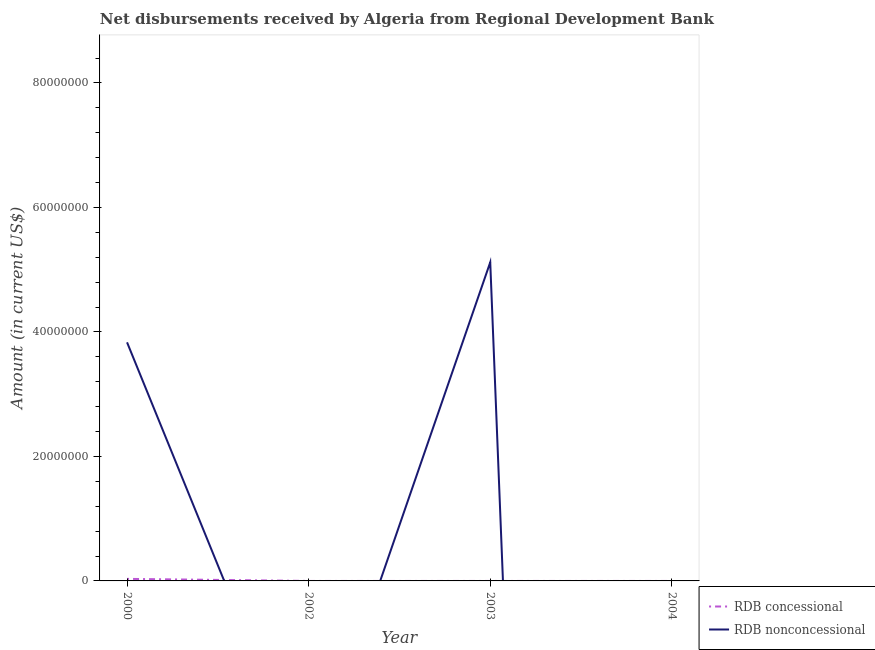Across all years, what is the maximum net non concessional disbursements from rdb?
Ensure brevity in your answer.  5.12e+07. Across all years, what is the minimum net non concessional disbursements from rdb?
Offer a very short reply. 0. What is the total net non concessional disbursements from rdb in the graph?
Offer a very short reply. 8.95e+07. What is the average net concessional disbursements from rdb per year?
Your response must be concise. 8.25e+04. In the year 2000, what is the difference between the net concessional disbursements from rdb and net non concessional disbursements from rdb?
Offer a very short reply. -3.80e+07. What is the difference between the highest and the lowest net non concessional disbursements from rdb?
Provide a succinct answer. 5.12e+07. Is the sum of the net non concessional disbursements from rdb in 2000 and 2003 greater than the maximum net concessional disbursements from rdb across all years?
Make the answer very short. Yes. Is the net non concessional disbursements from rdb strictly greater than the net concessional disbursements from rdb over the years?
Make the answer very short. No. Is the net non concessional disbursements from rdb strictly less than the net concessional disbursements from rdb over the years?
Offer a terse response. No. What is the difference between two consecutive major ticks on the Y-axis?
Ensure brevity in your answer.  2.00e+07. Are the values on the major ticks of Y-axis written in scientific E-notation?
Provide a short and direct response. No. Does the graph contain grids?
Keep it short and to the point. No. Where does the legend appear in the graph?
Your response must be concise. Bottom right. What is the title of the graph?
Your response must be concise. Net disbursements received by Algeria from Regional Development Bank. Does "Primary completion rate" appear as one of the legend labels in the graph?
Offer a very short reply. No. What is the Amount (in current US$) in RDB nonconcessional in 2000?
Make the answer very short. 3.83e+07. What is the Amount (in current US$) in RDB concessional in 2003?
Your answer should be very brief. 0. What is the Amount (in current US$) in RDB nonconcessional in 2003?
Give a very brief answer. 5.12e+07. What is the Amount (in current US$) in RDB concessional in 2004?
Make the answer very short. 0. What is the Amount (in current US$) in RDB nonconcessional in 2004?
Give a very brief answer. 0. Across all years, what is the maximum Amount (in current US$) in RDB nonconcessional?
Your answer should be compact. 5.12e+07. What is the total Amount (in current US$) in RDB nonconcessional in the graph?
Provide a succinct answer. 8.95e+07. What is the difference between the Amount (in current US$) of RDB nonconcessional in 2000 and that in 2003?
Your response must be concise. -1.29e+07. What is the difference between the Amount (in current US$) of RDB concessional in 2000 and the Amount (in current US$) of RDB nonconcessional in 2003?
Offer a very short reply. -5.09e+07. What is the average Amount (in current US$) in RDB concessional per year?
Give a very brief answer. 8.25e+04. What is the average Amount (in current US$) in RDB nonconcessional per year?
Give a very brief answer. 2.24e+07. In the year 2000, what is the difference between the Amount (in current US$) in RDB concessional and Amount (in current US$) in RDB nonconcessional?
Make the answer very short. -3.80e+07. What is the ratio of the Amount (in current US$) in RDB nonconcessional in 2000 to that in 2003?
Your answer should be compact. 0.75. What is the difference between the highest and the lowest Amount (in current US$) in RDB concessional?
Give a very brief answer. 3.30e+05. What is the difference between the highest and the lowest Amount (in current US$) of RDB nonconcessional?
Offer a terse response. 5.12e+07. 